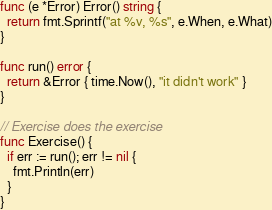<code> <loc_0><loc_0><loc_500><loc_500><_Go_>func (e *Error) Error() string {
  return fmt.Sprintf("at %v, %s", e.When, e.What)
}

func run() error {
  return &Error { time.Now(), "it didn't work" }
}

// Exercise does the exercise
func Exercise() {
  if err := run(); err != nil {
    fmt.Println(err)
  }
}</code> 